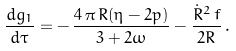Convert formula to latex. <formula><loc_0><loc_0><loc_500><loc_500>\frac { d g _ { 1 } } { d \tau } = - \, \frac { 4 \, \pi \, R ( \eta - 2 p ) } { 3 + 2 \omega } - \frac { \dot { R } ^ { 2 } \, f } { 2 R } \, .</formula> 